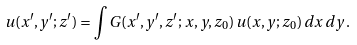<formula> <loc_0><loc_0><loc_500><loc_500>u ( x ^ { \prime } , y ^ { \prime } ; z ^ { \prime } ) = \int G ( x ^ { \prime } , y ^ { \prime } , z ^ { \prime } ; \, x , y , z _ { 0 } ) \, u ( x , y ; z _ { 0 } ) \, d x \, d y \, .</formula> 